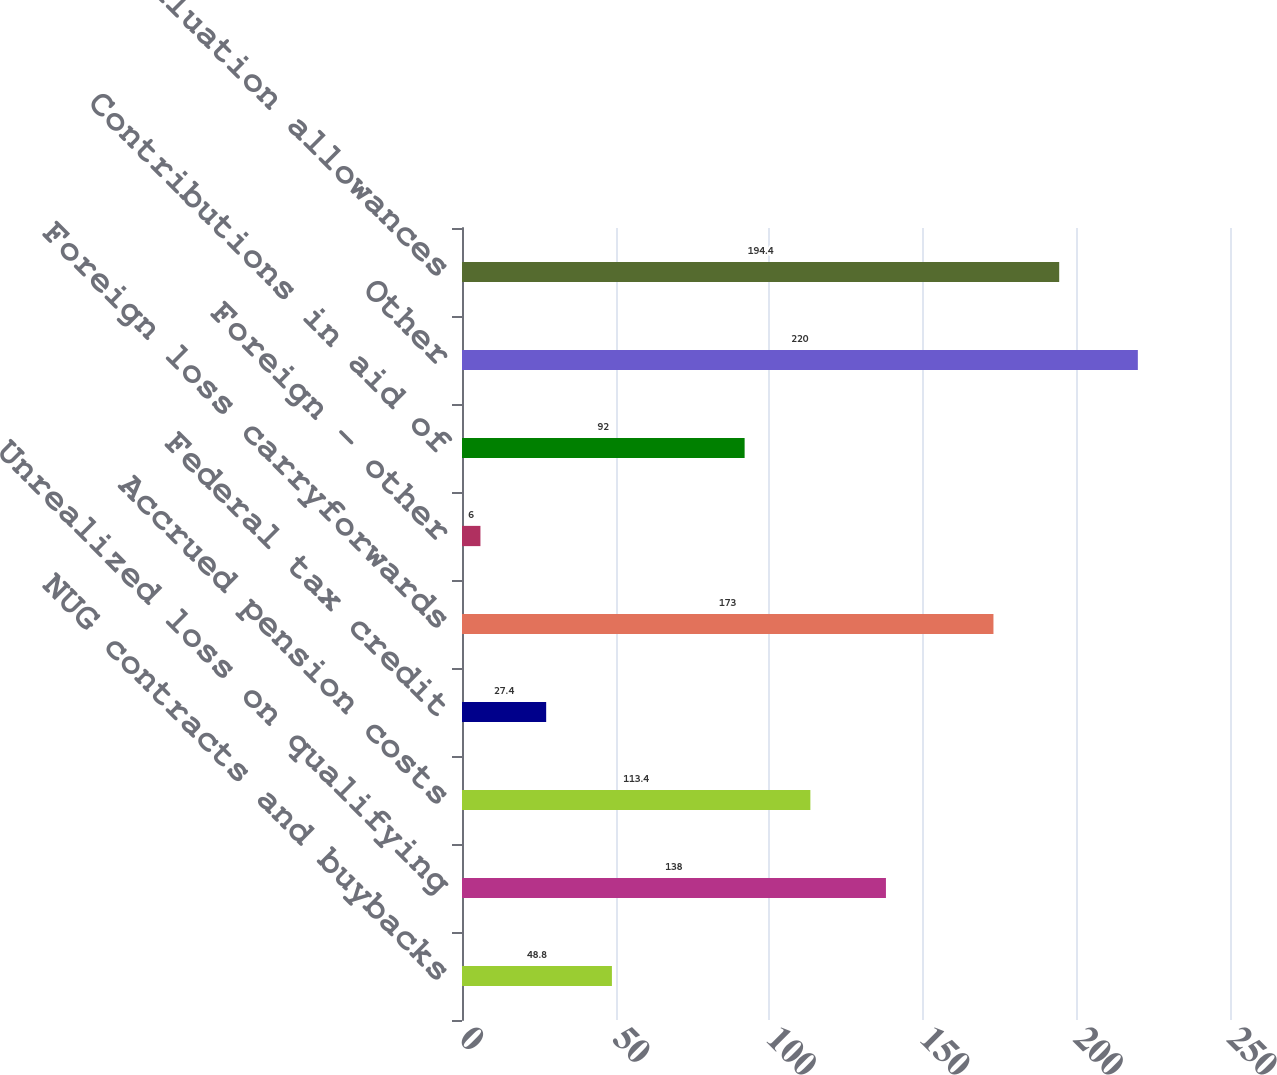Convert chart to OTSL. <chart><loc_0><loc_0><loc_500><loc_500><bar_chart><fcel>NUG contracts and buybacks<fcel>Unrealized loss on qualifying<fcel>Accrued pension costs<fcel>Federal tax credit<fcel>Foreign loss carryforwards<fcel>Foreign - other<fcel>Contributions in aid of<fcel>Other<fcel>Valuation allowances<nl><fcel>48.8<fcel>138<fcel>113.4<fcel>27.4<fcel>173<fcel>6<fcel>92<fcel>220<fcel>194.4<nl></chart> 